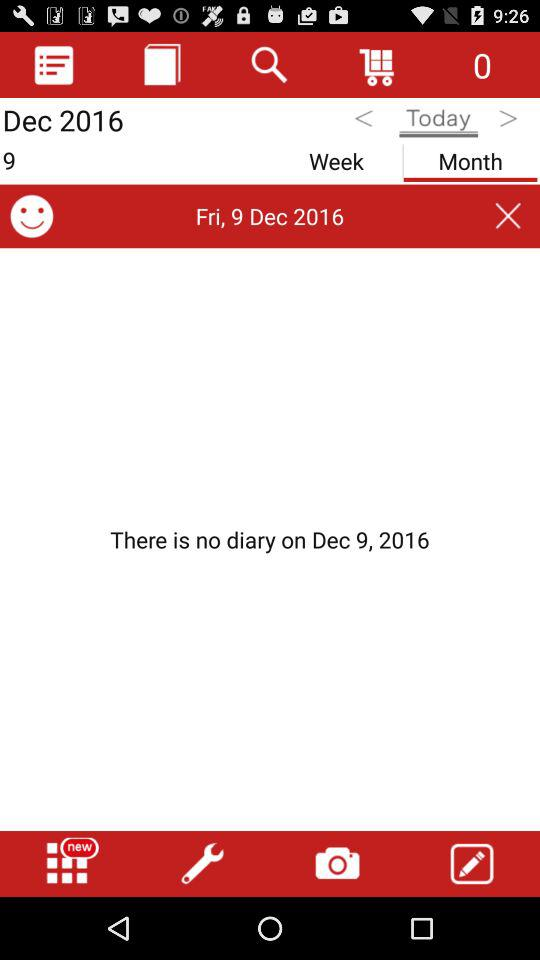Which date is selected to get the diary details? The selected date is Friday, December 9, 2016. 